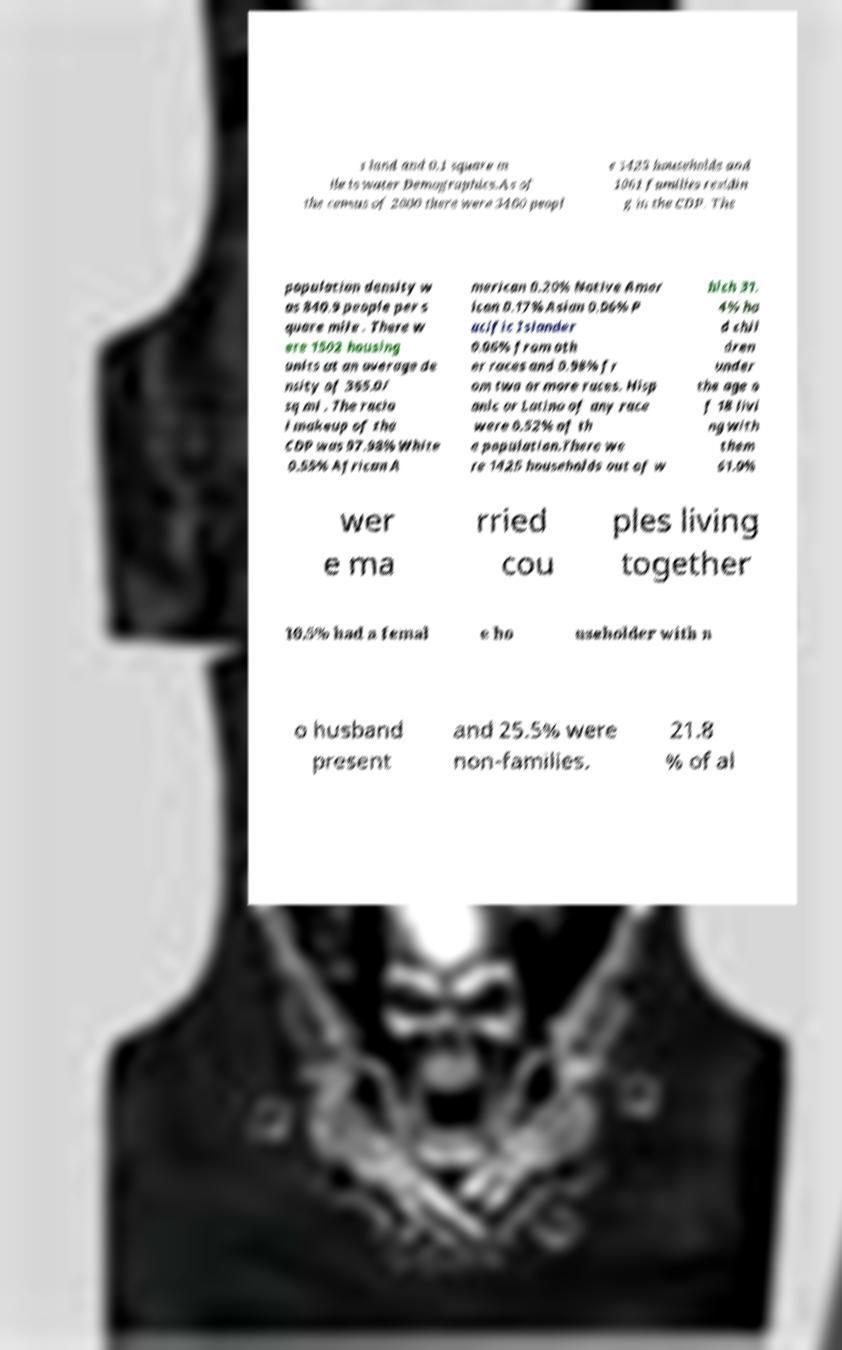What messages or text are displayed in this image? I need them in a readable, typed format. s land and 0.1 square m ile is water.Demographics.As of the census of 2000 there were 3460 peopl e 1425 households and 1061 families residin g in the CDP. The population density w as 840.9 people per s quare mile . There w ere 1502 housing units at an average de nsity of 365.0/ sq mi . The racia l makeup of the CDP was 97.98% White 0.55% African A merican 0.20% Native Amer ican 0.17% Asian 0.06% P acific Islander 0.06% from oth er races and 0.98% fr om two or more races. Hisp anic or Latino of any race were 0.52% of th e population.There we re 1425 households out of w hich 31. 4% ha d chil dren under the age o f 18 livi ng with them 61.0% wer e ma rried cou ples living together 10.5% had a femal e ho useholder with n o husband present and 25.5% were non-families. 21.8 % of al 